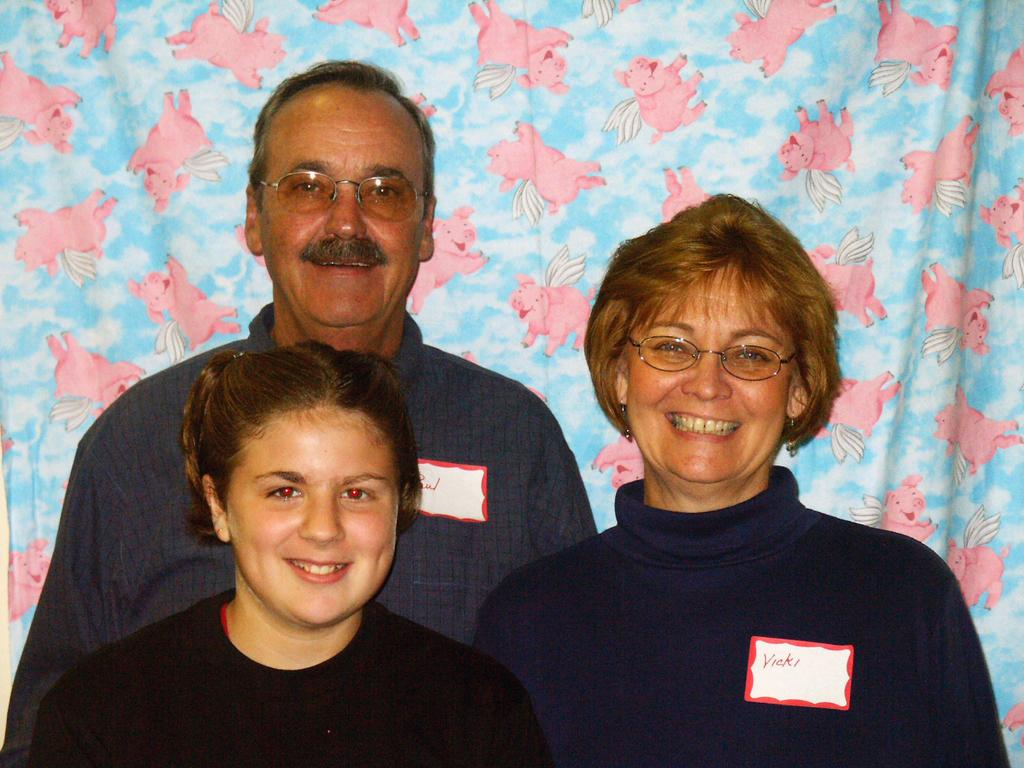How many people are in the image? There are three people in the image. What are the people doing in the image? The people are standing and smiling. What can be seen in the background of the image? There is a curtain in the background of the image. What is depicted on the curtain? There are pictures of pigs and a picture of the sky on the curtain. What type of sound can be heard coming from the volcano in the image? There is no volcano present in the image, so it's not possible to determine what, if any, sound might be heard. 